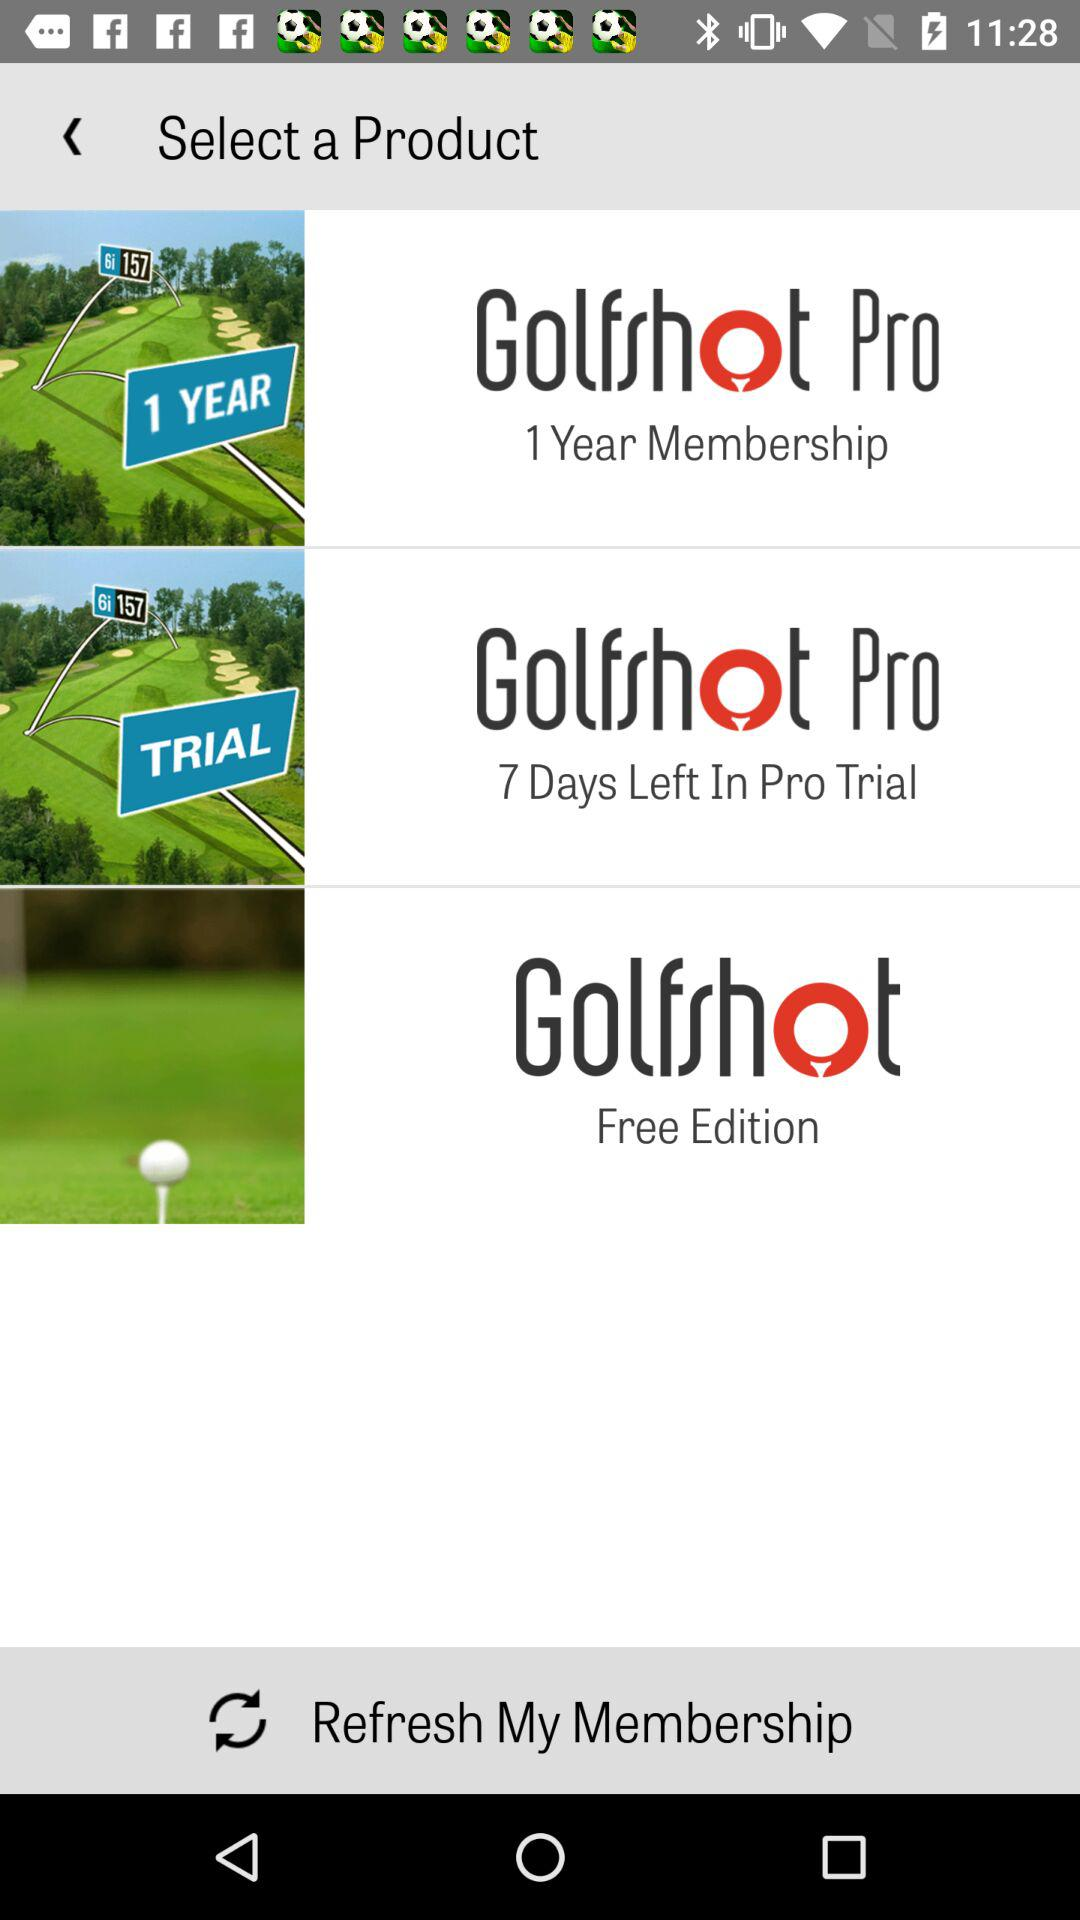How many products are available for purchase?
Answer the question using a single word or phrase. 3 